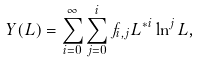<formula> <loc_0><loc_0><loc_500><loc_500>Y ( L ) = \sum _ { i = 0 } ^ { \infty } \sum _ { j = 0 } ^ { i } f _ { i , j } { L ^ { * } } ^ { i } \ln ^ { j } L ,</formula> 